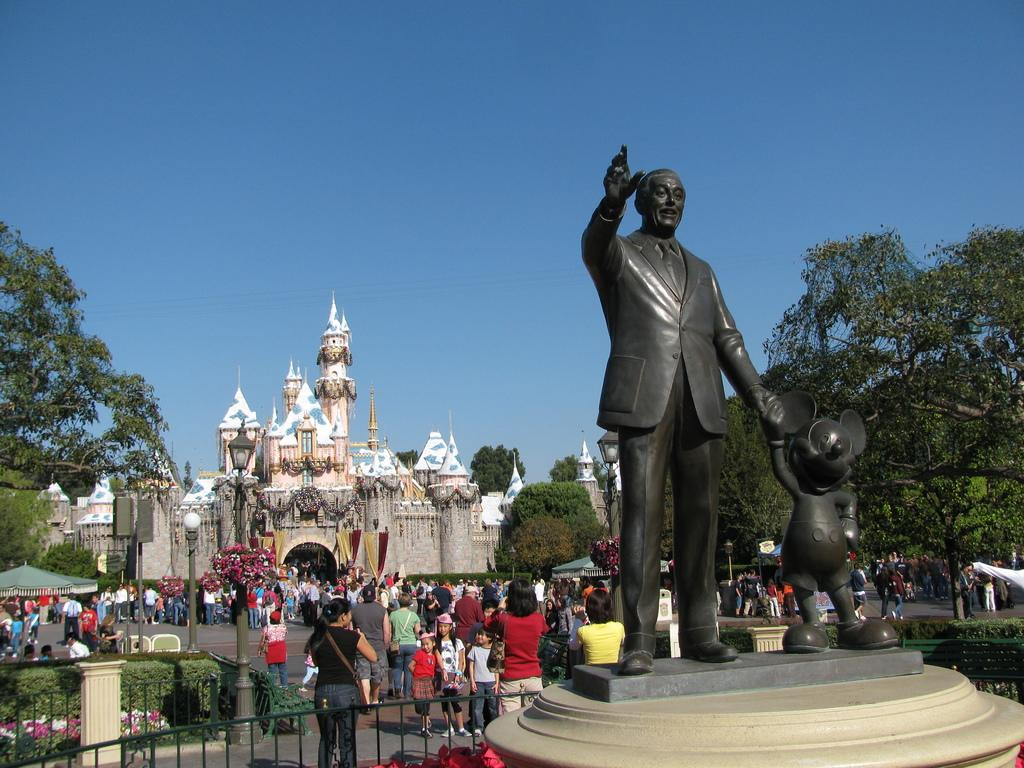What type of vegetation can be seen in the image? There are trees in the image. What type of objects are present in the image that are not living? There are black color statues, fencing, buildings, light poles, tents, and colorful flowers in the image. What can be seen in the sky in the image? The sky is blue in the image. Are there any people present in the image? Yes, there are people in the image. How does the alarm sound in the image? There is no alarm present in the image. Can you fold the trees in the image? No, the trees cannot be folded, as they are real, living vegetation. 